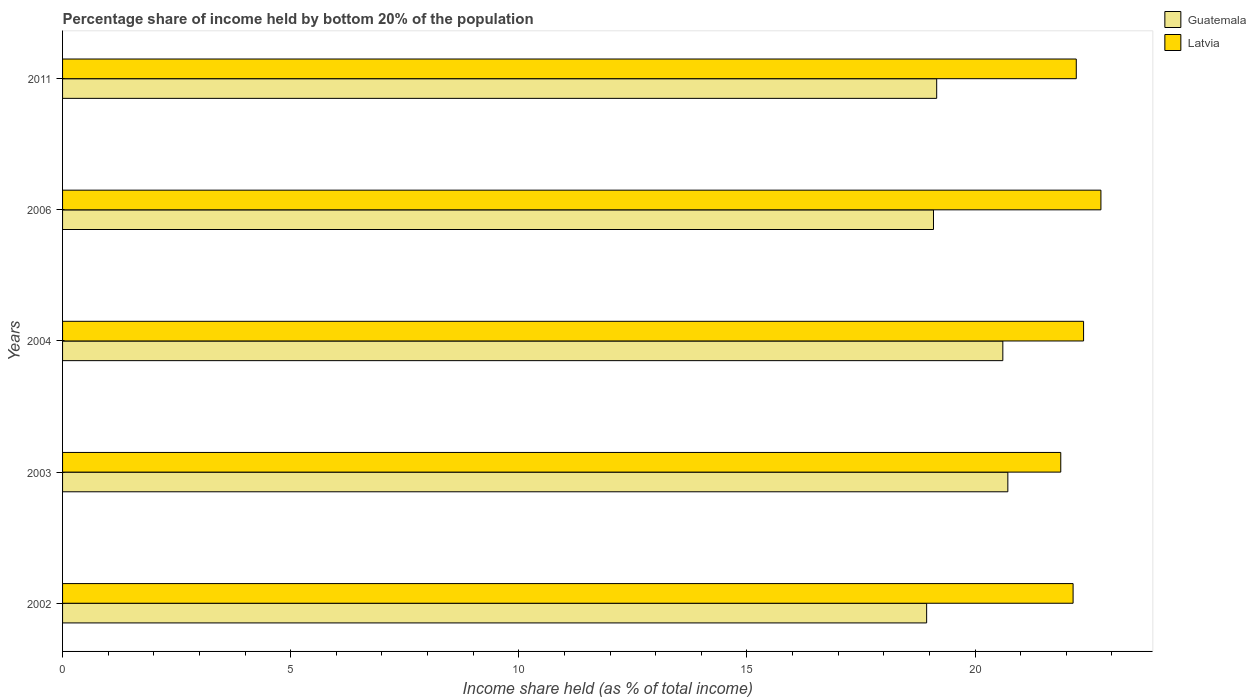How many bars are there on the 3rd tick from the bottom?
Your response must be concise. 2. What is the label of the 5th group of bars from the top?
Your answer should be very brief. 2002. In how many cases, is the number of bars for a given year not equal to the number of legend labels?
Keep it short and to the point. 0. What is the share of income held by bottom 20% of the population in Guatemala in 2004?
Offer a terse response. 20.61. Across all years, what is the maximum share of income held by bottom 20% of the population in Guatemala?
Provide a short and direct response. 20.72. Across all years, what is the minimum share of income held by bottom 20% of the population in Guatemala?
Offer a terse response. 18.94. What is the total share of income held by bottom 20% of the population in Latvia in the graph?
Offer a terse response. 111.39. What is the difference between the share of income held by bottom 20% of the population in Latvia in 2004 and that in 2011?
Provide a succinct answer. 0.16. What is the difference between the share of income held by bottom 20% of the population in Guatemala in 2011 and the share of income held by bottom 20% of the population in Latvia in 2002?
Your answer should be very brief. -2.99. What is the average share of income held by bottom 20% of the population in Latvia per year?
Keep it short and to the point. 22.28. In the year 2006, what is the difference between the share of income held by bottom 20% of the population in Latvia and share of income held by bottom 20% of the population in Guatemala?
Offer a very short reply. 3.67. What is the ratio of the share of income held by bottom 20% of the population in Guatemala in 2002 to that in 2003?
Your answer should be very brief. 0.91. Is the difference between the share of income held by bottom 20% of the population in Latvia in 2006 and 2011 greater than the difference between the share of income held by bottom 20% of the population in Guatemala in 2006 and 2011?
Your answer should be very brief. Yes. What is the difference between the highest and the second highest share of income held by bottom 20% of the population in Guatemala?
Your answer should be very brief. 0.11. What is the difference between the highest and the lowest share of income held by bottom 20% of the population in Guatemala?
Your response must be concise. 1.78. Is the sum of the share of income held by bottom 20% of the population in Latvia in 2003 and 2006 greater than the maximum share of income held by bottom 20% of the population in Guatemala across all years?
Your answer should be very brief. Yes. What does the 1st bar from the top in 2006 represents?
Your answer should be compact. Latvia. What does the 1st bar from the bottom in 2003 represents?
Offer a very short reply. Guatemala. Does the graph contain any zero values?
Keep it short and to the point. No. How many legend labels are there?
Give a very brief answer. 2. How are the legend labels stacked?
Your answer should be compact. Vertical. What is the title of the graph?
Provide a short and direct response. Percentage share of income held by bottom 20% of the population. Does "Faeroe Islands" appear as one of the legend labels in the graph?
Your answer should be compact. No. What is the label or title of the X-axis?
Your answer should be very brief. Income share held (as % of total income). What is the Income share held (as % of total income) in Guatemala in 2002?
Your answer should be very brief. 18.94. What is the Income share held (as % of total income) in Latvia in 2002?
Offer a terse response. 22.15. What is the Income share held (as % of total income) in Guatemala in 2003?
Your answer should be very brief. 20.72. What is the Income share held (as % of total income) in Latvia in 2003?
Ensure brevity in your answer.  21.88. What is the Income share held (as % of total income) in Guatemala in 2004?
Ensure brevity in your answer.  20.61. What is the Income share held (as % of total income) in Latvia in 2004?
Your answer should be very brief. 22.38. What is the Income share held (as % of total income) of Guatemala in 2006?
Provide a short and direct response. 19.09. What is the Income share held (as % of total income) in Latvia in 2006?
Your response must be concise. 22.76. What is the Income share held (as % of total income) in Guatemala in 2011?
Ensure brevity in your answer.  19.16. What is the Income share held (as % of total income) of Latvia in 2011?
Keep it short and to the point. 22.22. Across all years, what is the maximum Income share held (as % of total income) in Guatemala?
Ensure brevity in your answer.  20.72. Across all years, what is the maximum Income share held (as % of total income) of Latvia?
Keep it short and to the point. 22.76. Across all years, what is the minimum Income share held (as % of total income) in Guatemala?
Ensure brevity in your answer.  18.94. Across all years, what is the minimum Income share held (as % of total income) in Latvia?
Your answer should be very brief. 21.88. What is the total Income share held (as % of total income) of Guatemala in the graph?
Offer a very short reply. 98.52. What is the total Income share held (as % of total income) in Latvia in the graph?
Offer a very short reply. 111.39. What is the difference between the Income share held (as % of total income) in Guatemala in 2002 and that in 2003?
Offer a terse response. -1.78. What is the difference between the Income share held (as % of total income) of Latvia in 2002 and that in 2003?
Keep it short and to the point. 0.27. What is the difference between the Income share held (as % of total income) of Guatemala in 2002 and that in 2004?
Provide a succinct answer. -1.67. What is the difference between the Income share held (as % of total income) in Latvia in 2002 and that in 2004?
Keep it short and to the point. -0.23. What is the difference between the Income share held (as % of total income) in Guatemala in 2002 and that in 2006?
Your response must be concise. -0.15. What is the difference between the Income share held (as % of total income) in Latvia in 2002 and that in 2006?
Ensure brevity in your answer.  -0.61. What is the difference between the Income share held (as % of total income) in Guatemala in 2002 and that in 2011?
Offer a very short reply. -0.22. What is the difference between the Income share held (as % of total income) of Latvia in 2002 and that in 2011?
Your answer should be very brief. -0.07. What is the difference between the Income share held (as % of total income) in Guatemala in 2003 and that in 2004?
Provide a short and direct response. 0.11. What is the difference between the Income share held (as % of total income) of Guatemala in 2003 and that in 2006?
Offer a very short reply. 1.63. What is the difference between the Income share held (as % of total income) of Latvia in 2003 and that in 2006?
Give a very brief answer. -0.88. What is the difference between the Income share held (as % of total income) of Guatemala in 2003 and that in 2011?
Give a very brief answer. 1.56. What is the difference between the Income share held (as % of total income) in Latvia in 2003 and that in 2011?
Your answer should be compact. -0.34. What is the difference between the Income share held (as % of total income) of Guatemala in 2004 and that in 2006?
Your answer should be compact. 1.52. What is the difference between the Income share held (as % of total income) of Latvia in 2004 and that in 2006?
Provide a short and direct response. -0.38. What is the difference between the Income share held (as % of total income) in Guatemala in 2004 and that in 2011?
Provide a short and direct response. 1.45. What is the difference between the Income share held (as % of total income) of Latvia in 2004 and that in 2011?
Your response must be concise. 0.16. What is the difference between the Income share held (as % of total income) of Guatemala in 2006 and that in 2011?
Your answer should be compact. -0.07. What is the difference between the Income share held (as % of total income) in Latvia in 2006 and that in 2011?
Provide a short and direct response. 0.54. What is the difference between the Income share held (as % of total income) of Guatemala in 2002 and the Income share held (as % of total income) of Latvia in 2003?
Offer a very short reply. -2.94. What is the difference between the Income share held (as % of total income) in Guatemala in 2002 and the Income share held (as % of total income) in Latvia in 2004?
Ensure brevity in your answer.  -3.44. What is the difference between the Income share held (as % of total income) of Guatemala in 2002 and the Income share held (as % of total income) of Latvia in 2006?
Keep it short and to the point. -3.82. What is the difference between the Income share held (as % of total income) in Guatemala in 2002 and the Income share held (as % of total income) in Latvia in 2011?
Provide a succinct answer. -3.28. What is the difference between the Income share held (as % of total income) of Guatemala in 2003 and the Income share held (as % of total income) of Latvia in 2004?
Offer a very short reply. -1.66. What is the difference between the Income share held (as % of total income) of Guatemala in 2003 and the Income share held (as % of total income) of Latvia in 2006?
Give a very brief answer. -2.04. What is the difference between the Income share held (as % of total income) of Guatemala in 2003 and the Income share held (as % of total income) of Latvia in 2011?
Provide a short and direct response. -1.5. What is the difference between the Income share held (as % of total income) of Guatemala in 2004 and the Income share held (as % of total income) of Latvia in 2006?
Provide a short and direct response. -2.15. What is the difference between the Income share held (as % of total income) of Guatemala in 2004 and the Income share held (as % of total income) of Latvia in 2011?
Make the answer very short. -1.61. What is the difference between the Income share held (as % of total income) of Guatemala in 2006 and the Income share held (as % of total income) of Latvia in 2011?
Your answer should be compact. -3.13. What is the average Income share held (as % of total income) in Guatemala per year?
Make the answer very short. 19.7. What is the average Income share held (as % of total income) of Latvia per year?
Give a very brief answer. 22.28. In the year 2002, what is the difference between the Income share held (as % of total income) of Guatemala and Income share held (as % of total income) of Latvia?
Your answer should be very brief. -3.21. In the year 2003, what is the difference between the Income share held (as % of total income) in Guatemala and Income share held (as % of total income) in Latvia?
Make the answer very short. -1.16. In the year 2004, what is the difference between the Income share held (as % of total income) of Guatemala and Income share held (as % of total income) of Latvia?
Your answer should be compact. -1.77. In the year 2006, what is the difference between the Income share held (as % of total income) of Guatemala and Income share held (as % of total income) of Latvia?
Make the answer very short. -3.67. In the year 2011, what is the difference between the Income share held (as % of total income) of Guatemala and Income share held (as % of total income) of Latvia?
Make the answer very short. -3.06. What is the ratio of the Income share held (as % of total income) of Guatemala in 2002 to that in 2003?
Your answer should be very brief. 0.91. What is the ratio of the Income share held (as % of total income) in Latvia in 2002 to that in 2003?
Provide a succinct answer. 1.01. What is the ratio of the Income share held (as % of total income) in Guatemala in 2002 to that in 2004?
Give a very brief answer. 0.92. What is the ratio of the Income share held (as % of total income) in Latvia in 2002 to that in 2006?
Give a very brief answer. 0.97. What is the ratio of the Income share held (as % of total income) of Latvia in 2002 to that in 2011?
Provide a succinct answer. 1. What is the ratio of the Income share held (as % of total income) in Guatemala in 2003 to that in 2004?
Give a very brief answer. 1.01. What is the ratio of the Income share held (as % of total income) in Latvia in 2003 to that in 2004?
Offer a terse response. 0.98. What is the ratio of the Income share held (as % of total income) of Guatemala in 2003 to that in 2006?
Provide a succinct answer. 1.09. What is the ratio of the Income share held (as % of total income) in Latvia in 2003 to that in 2006?
Ensure brevity in your answer.  0.96. What is the ratio of the Income share held (as % of total income) of Guatemala in 2003 to that in 2011?
Give a very brief answer. 1.08. What is the ratio of the Income share held (as % of total income) of Latvia in 2003 to that in 2011?
Your response must be concise. 0.98. What is the ratio of the Income share held (as % of total income) of Guatemala in 2004 to that in 2006?
Offer a terse response. 1.08. What is the ratio of the Income share held (as % of total income) in Latvia in 2004 to that in 2006?
Make the answer very short. 0.98. What is the ratio of the Income share held (as % of total income) of Guatemala in 2004 to that in 2011?
Make the answer very short. 1.08. What is the ratio of the Income share held (as % of total income) of Latvia in 2004 to that in 2011?
Your answer should be very brief. 1.01. What is the ratio of the Income share held (as % of total income) in Guatemala in 2006 to that in 2011?
Keep it short and to the point. 1. What is the ratio of the Income share held (as % of total income) in Latvia in 2006 to that in 2011?
Your response must be concise. 1.02. What is the difference between the highest and the second highest Income share held (as % of total income) of Guatemala?
Provide a short and direct response. 0.11. What is the difference between the highest and the second highest Income share held (as % of total income) of Latvia?
Keep it short and to the point. 0.38. What is the difference between the highest and the lowest Income share held (as % of total income) of Guatemala?
Keep it short and to the point. 1.78. What is the difference between the highest and the lowest Income share held (as % of total income) of Latvia?
Your answer should be very brief. 0.88. 